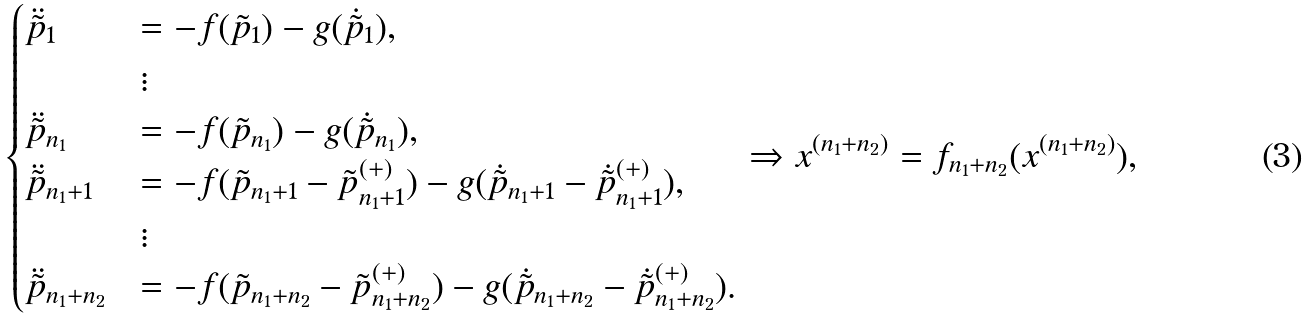Convert formula to latex. <formula><loc_0><loc_0><loc_500><loc_500>\begin{cases} \ddot { \tilde { p } } _ { 1 } & = - f ( \tilde { p } _ { 1 } ) - g ( \dot { \tilde { p } } _ { 1 } ) , \\ & \vdots \\ \ddot { \tilde { p } } _ { n _ { 1 } } & = - f ( \tilde { p } _ { n _ { 1 } } ) - g ( \dot { \tilde { p } } _ { n _ { 1 } } ) , \\ \ddot { \tilde { p } } _ { n _ { 1 } + 1 } & = - f ( \tilde { p } _ { n _ { 1 } + 1 } - \tilde { p } _ { n _ { 1 } + 1 } ^ { ( + ) } ) - g ( \dot { \tilde { p } } _ { n _ { 1 } + 1 } - \dot { \tilde { p } } _ { n _ { 1 } + 1 } ^ { ( + ) } ) , \\ & \vdots \\ \ddot { \tilde { p } } _ { n _ { 1 } + n _ { 2 } } & = - f ( \tilde { p } _ { n _ { 1 } + n _ { 2 } } - \tilde { p } _ { n _ { 1 } + n _ { 2 } } ^ { ( + ) } ) - g ( \dot { \tilde { p } } _ { n _ { 1 } + n _ { 2 } } - \dot { \tilde { p } } _ { n _ { 1 } + n _ { 2 } } ^ { ( + ) } ) . \end{cases} \Rightarrow x ^ { ( n _ { 1 } + n _ { 2 } ) } = f _ { n _ { 1 } + n _ { 2 } } ( x ^ { ( n _ { 1 } + n _ { 2 } ) } ) ,</formula> 